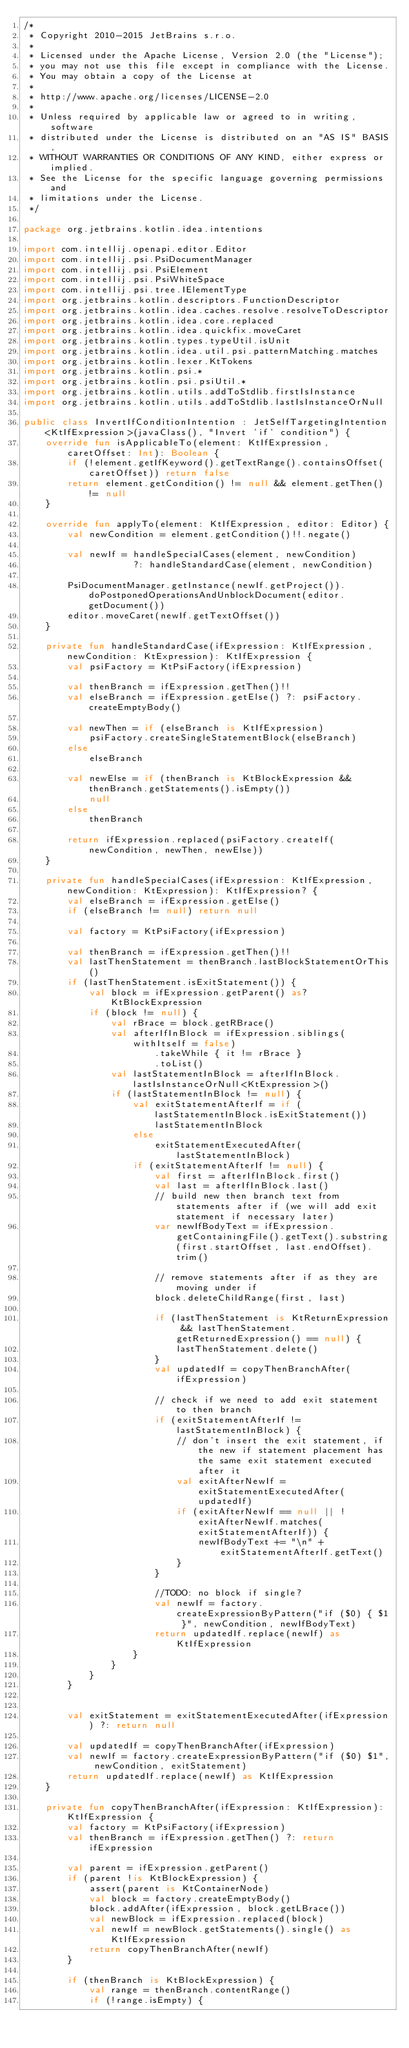<code> <loc_0><loc_0><loc_500><loc_500><_Kotlin_>/*
 * Copyright 2010-2015 JetBrains s.r.o.
 *
 * Licensed under the Apache License, Version 2.0 (the "License");
 * you may not use this file except in compliance with the License.
 * You may obtain a copy of the License at
 *
 * http://www.apache.org/licenses/LICENSE-2.0
 *
 * Unless required by applicable law or agreed to in writing, software
 * distributed under the License is distributed on an "AS IS" BASIS,
 * WITHOUT WARRANTIES OR CONDITIONS OF ANY KIND, either express or implied.
 * See the License for the specific language governing permissions and
 * limitations under the License.
 */

package org.jetbrains.kotlin.idea.intentions

import com.intellij.openapi.editor.Editor
import com.intellij.psi.PsiDocumentManager
import com.intellij.psi.PsiElement
import com.intellij.psi.PsiWhiteSpace
import com.intellij.psi.tree.IElementType
import org.jetbrains.kotlin.descriptors.FunctionDescriptor
import org.jetbrains.kotlin.idea.caches.resolve.resolveToDescriptor
import org.jetbrains.kotlin.idea.core.replaced
import org.jetbrains.kotlin.idea.quickfix.moveCaret
import org.jetbrains.kotlin.types.typeUtil.isUnit
import org.jetbrains.kotlin.idea.util.psi.patternMatching.matches
import org.jetbrains.kotlin.lexer.KtTokens
import org.jetbrains.kotlin.psi.*
import org.jetbrains.kotlin.psi.psiUtil.*
import org.jetbrains.kotlin.utils.addToStdlib.firstIsInstance
import org.jetbrains.kotlin.utils.addToStdlib.lastIsInstanceOrNull

public class InvertIfConditionIntention : JetSelfTargetingIntention<KtIfExpression>(javaClass(), "Invert 'if' condition") {
    override fun isApplicableTo(element: KtIfExpression, caretOffset: Int): Boolean {
        if (!element.getIfKeyword().getTextRange().containsOffset(caretOffset)) return false
        return element.getCondition() != null && element.getThen() != null
    }

    override fun applyTo(element: KtIfExpression, editor: Editor) {
        val newCondition = element.getCondition()!!.negate()

        val newIf = handleSpecialCases(element, newCondition)
                    ?: handleStandardCase(element, newCondition)

        PsiDocumentManager.getInstance(newIf.getProject()).doPostponedOperationsAndUnblockDocument(editor.getDocument())
        editor.moveCaret(newIf.getTextOffset())
    }

    private fun handleStandardCase(ifExpression: KtIfExpression, newCondition: KtExpression): KtIfExpression {
        val psiFactory = KtPsiFactory(ifExpression)

        val thenBranch = ifExpression.getThen()!!
        val elseBranch = ifExpression.getElse() ?: psiFactory.createEmptyBody()

        val newThen = if (elseBranch is KtIfExpression)
            psiFactory.createSingleStatementBlock(elseBranch)
        else
            elseBranch

        val newElse = if (thenBranch is KtBlockExpression && thenBranch.getStatements().isEmpty())
            null
        else
            thenBranch

        return ifExpression.replaced(psiFactory.createIf(newCondition, newThen, newElse))
    }

    private fun handleSpecialCases(ifExpression: KtIfExpression, newCondition: KtExpression): KtIfExpression? {
        val elseBranch = ifExpression.getElse()
        if (elseBranch != null) return null

        val factory = KtPsiFactory(ifExpression)

        val thenBranch = ifExpression.getThen()!!
        val lastThenStatement = thenBranch.lastBlockStatementOrThis()
        if (lastThenStatement.isExitStatement()) {
            val block = ifExpression.getParent() as? KtBlockExpression
            if (block != null) {
                val rBrace = block.getRBrace()
                val afterIfInBlock = ifExpression.siblings(withItself = false)
                        .takeWhile { it != rBrace }
                        .toList()
                val lastStatementInBlock = afterIfInBlock.lastIsInstanceOrNull<KtExpression>()
                if (lastStatementInBlock != null) {
                    val exitStatementAfterIf = if (lastStatementInBlock.isExitStatement())
                        lastStatementInBlock
                    else
                        exitStatementExecutedAfter(lastStatementInBlock)
                    if (exitStatementAfterIf != null) {
                        val first = afterIfInBlock.first()
                        val last = afterIfInBlock.last()
                        // build new then branch text from statements after if (we will add exit statement if necessary later)
                        var newIfBodyText = ifExpression.getContainingFile().getText().substring(first.startOffset, last.endOffset).trim()

                        // remove statements after if as they are moving under if
                        block.deleteChildRange(first, last)

                        if (lastThenStatement is KtReturnExpression && lastThenStatement.getReturnedExpression() == null) {
                            lastThenStatement.delete()
                        }
                        val updatedIf = copyThenBranchAfter(ifExpression)

                        // check if we need to add exit statement to then branch
                        if (exitStatementAfterIf != lastStatementInBlock) {
                            // don't insert the exit statement, if the new if statement placement has the same exit statement executed after it
                            val exitAfterNewIf = exitStatementExecutedAfter(updatedIf)
                            if (exitAfterNewIf == null || !exitAfterNewIf.matches(exitStatementAfterIf)) {
                                newIfBodyText += "\n" + exitStatementAfterIf.getText()
                            }
                        }

                        //TODO: no block if single?
                        val newIf = factory.createExpressionByPattern("if ($0) { $1 }", newCondition, newIfBodyText)
                        return updatedIf.replace(newIf) as KtIfExpression
                    }
                }
            }
        }


        val exitStatement = exitStatementExecutedAfter(ifExpression) ?: return null

        val updatedIf = copyThenBranchAfter(ifExpression)
        val newIf = factory.createExpressionByPattern("if ($0) $1", newCondition, exitStatement)
        return updatedIf.replace(newIf) as KtIfExpression
    }

    private fun copyThenBranchAfter(ifExpression: KtIfExpression): KtIfExpression {
        val factory = KtPsiFactory(ifExpression)
        val thenBranch = ifExpression.getThen() ?: return ifExpression

        val parent = ifExpression.getParent()
        if (parent !is KtBlockExpression) {
            assert(parent is KtContainerNode)
            val block = factory.createEmptyBody()
            block.addAfter(ifExpression, block.getLBrace())
            val newBlock = ifExpression.replaced(block)
            val newIf = newBlock.getStatements().single() as KtIfExpression
            return copyThenBranchAfter(newIf)
        }

        if (thenBranch is KtBlockExpression) {
            val range = thenBranch.contentRange()
            if (!range.isEmpty) {</code> 